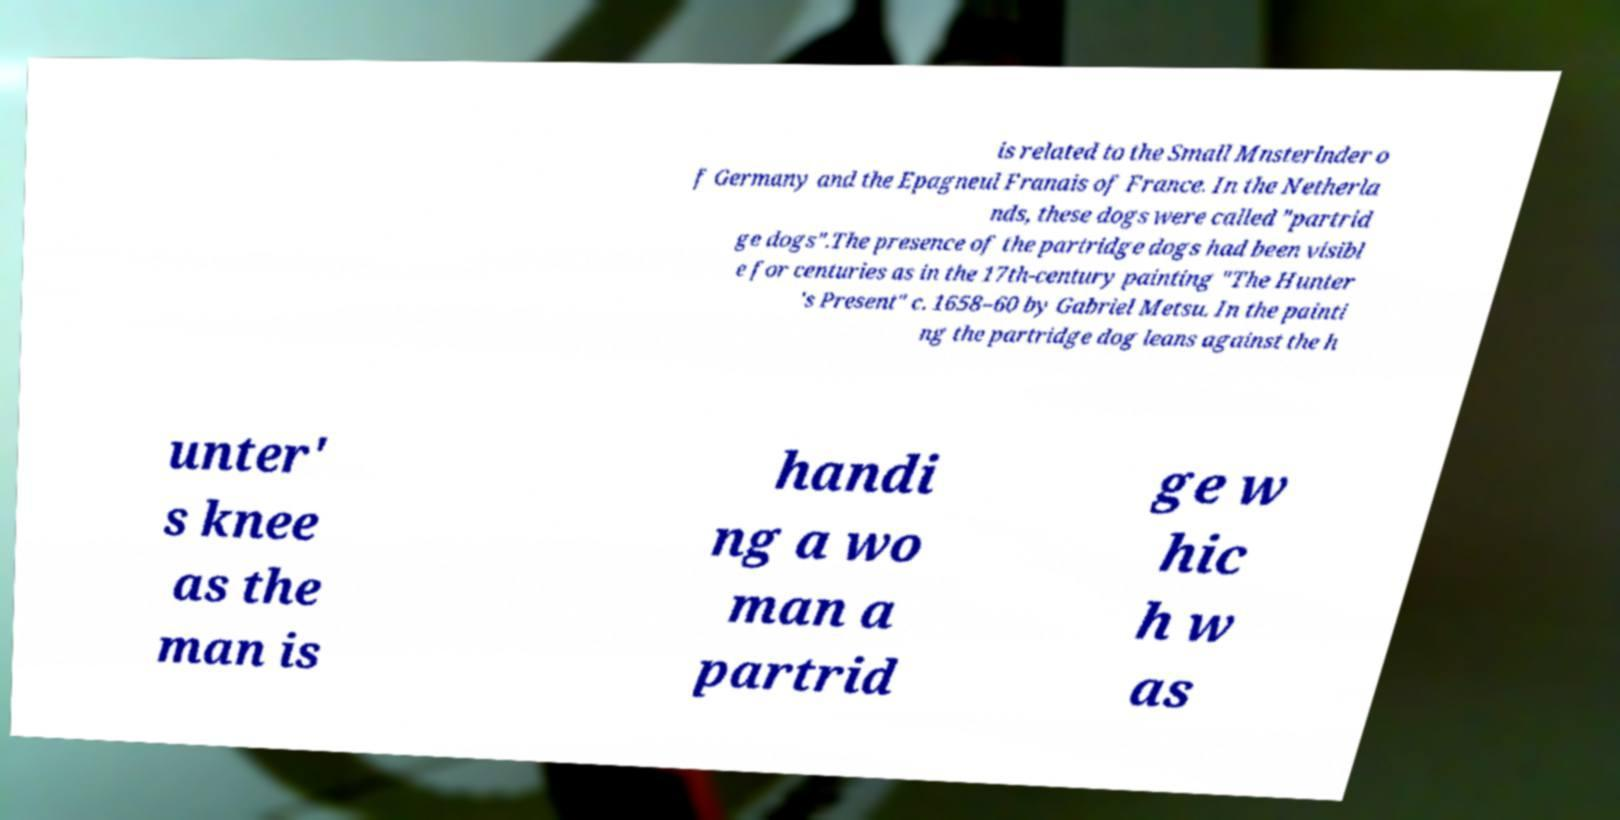Can you accurately transcribe the text from the provided image for me? is related to the Small Mnsterlnder o f Germany and the Epagneul Franais of France. In the Netherla nds, these dogs were called "partrid ge dogs".The presence of the partridge dogs had been visibl e for centuries as in the 17th-century painting "The Hunter 's Present" c. 1658–60 by Gabriel Metsu. In the painti ng the partridge dog leans against the h unter' s knee as the man is handi ng a wo man a partrid ge w hic h w as 